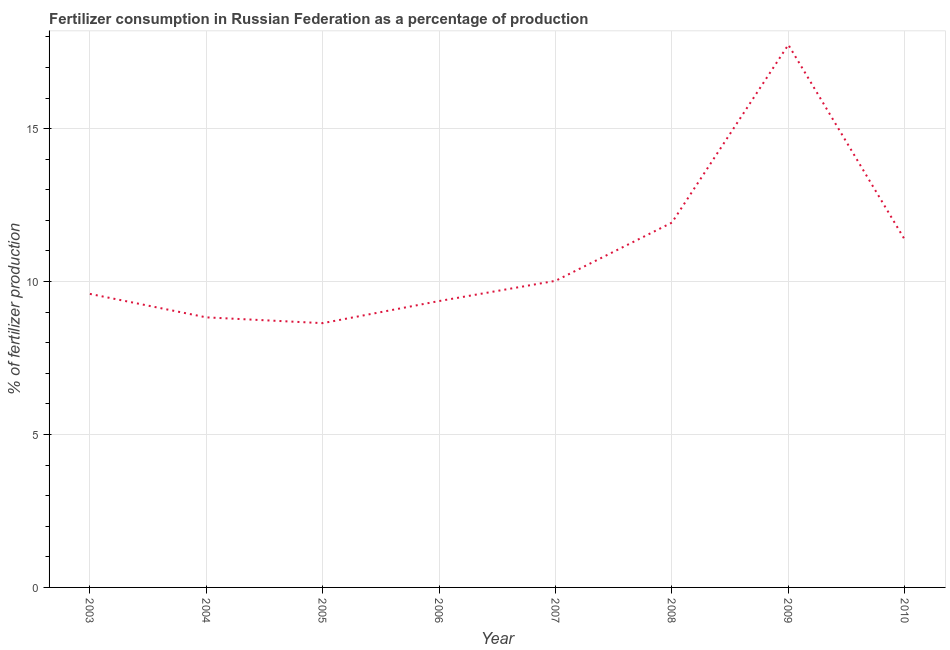What is the amount of fertilizer consumption in 2008?
Provide a succinct answer. 11.93. Across all years, what is the maximum amount of fertilizer consumption?
Give a very brief answer. 17.74. Across all years, what is the minimum amount of fertilizer consumption?
Your response must be concise. 8.64. In which year was the amount of fertilizer consumption minimum?
Provide a short and direct response. 2005. What is the sum of the amount of fertilizer consumption?
Provide a succinct answer. 87.49. What is the difference between the amount of fertilizer consumption in 2003 and 2009?
Your answer should be very brief. -8.15. What is the average amount of fertilizer consumption per year?
Ensure brevity in your answer.  10.94. What is the median amount of fertilizer consumption?
Give a very brief answer. 9.81. In how many years, is the amount of fertilizer consumption greater than 1 %?
Keep it short and to the point. 8. What is the ratio of the amount of fertilizer consumption in 2004 to that in 2008?
Keep it short and to the point. 0.74. Is the amount of fertilizer consumption in 2005 less than that in 2007?
Offer a terse response. Yes. Is the difference between the amount of fertilizer consumption in 2005 and 2007 greater than the difference between any two years?
Make the answer very short. No. What is the difference between the highest and the second highest amount of fertilizer consumption?
Provide a succinct answer. 5.81. Is the sum of the amount of fertilizer consumption in 2008 and 2010 greater than the maximum amount of fertilizer consumption across all years?
Provide a succinct answer. Yes. What is the difference between the highest and the lowest amount of fertilizer consumption?
Provide a succinct answer. 9.1. How many lines are there?
Your response must be concise. 1. What is the difference between two consecutive major ticks on the Y-axis?
Your answer should be compact. 5. Does the graph contain any zero values?
Offer a very short reply. No. What is the title of the graph?
Keep it short and to the point. Fertilizer consumption in Russian Federation as a percentage of production. What is the label or title of the X-axis?
Your answer should be very brief. Year. What is the label or title of the Y-axis?
Give a very brief answer. % of fertilizer production. What is the % of fertilizer production in 2003?
Your answer should be compact. 9.6. What is the % of fertilizer production in 2004?
Provide a short and direct response. 8.83. What is the % of fertilizer production in 2005?
Your answer should be very brief. 8.64. What is the % of fertilizer production in 2006?
Provide a succinct answer. 9.36. What is the % of fertilizer production of 2007?
Offer a terse response. 10.02. What is the % of fertilizer production in 2008?
Your response must be concise. 11.93. What is the % of fertilizer production of 2009?
Offer a very short reply. 17.74. What is the % of fertilizer production of 2010?
Provide a succinct answer. 11.37. What is the difference between the % of fertilizer production in 2003 and 2004?
Your answer should be very brief. 0.77. What is the difference between the % of fertilizer production in 2003 and 2005?
Provide a short and direct response. 0.96. What is the difference between the % of fertilizer production in 2003 and 2006?
Give a very brief answer. 0.23. What is the difference between the % of fertilizer production in 2003 and 2007?
Provide a succinct answer. -0.43. What is the difference between the % of fertilizer production in 2003 and 2008?
Your answer should be compact. -2.33. What is the difference between the % of fertilizer production in 2003 and 2009?
Offer a very short reply. -8.15. What is the difference between the % of fertilizer production in 2003 and 2010?
Your answer should be very brief. -1.77. What is the difference between the % of fertilizer production in 2004 and 2005?
Provide a short and direct response. 0.19. What is the difference between the % of fertilizer production in 2004 and 2006?
Keep it short and to the point. -0.53. What is the difference between the % of fertilizer production in 2004 and 2007?
Your response must be concise. -1.19. What is the difference between the % of fertilizer production in 2004 and 2008?
Your answer should be very brief. -3.1. What is the difference between the % of fertilizer production in 2004 and 2009?
Your response must be concise. -8.91. What is the difference between the % of fertilizer production in 2004 and 2010?
Your response must be concise. -2.54. What is the difference between the % of fertilizer production in 2005 and 2006?
Provide a short and direct response. -0.72. What is the difference between the % of fertilizer production in 2005 and 2007?
Offer a very short reply. -1.38. What is the difference between the % of fertilizer production in 2005 and 2008?
Keep it short and to the point. -3.29. What is the difference between the % of fertilizer production in 2005 and 2009?
Offer a terse response. -9.1. What is the difference between the % of fertilizer production in 2005 and 2010?
Your answer should be very brief. -2.73. What is the difference between the % of fertilizer production in 2006 and 2007?
Your answer should be compact. -0.66. What is the difference between the % of fertilizer production in 2006 and 2008?
Provide a succinct answer. -2.56. What is the difference between the % of fertilizer production in 2006 and 2009?
Make the answer very short. -8.38. What is the difference between the % of fertilizer production in 2006 and 2010?
Your response must be concise. -2.01. What is the difference between the % of fertilizer production in 2007 and 2008?
Keep it short and to the point. -1.9. What is the difference between the % of fertilizer production in 2007 and 2009?
Provide a short and direct response. -7.72. What is the difference between the % of fertilizer production in 2007 and 2010?
Offer a terse response. -1.35. What is the difference between the % of fertilizer production in 2008 and 2009?
Ensure brevity in your answer.  -5.81. What is the difference between the % of fertilizer production in 2008 and 2010?
Your response must be concise. 0.56. What is the difference between the % of fertilizer production in 2009 and 2010?
Give a very brief answer. 6.37. What is the ratio of the % of fertilizer production in 2003 to that in 2004?
Your response must be concise. 1.09. What is the ratio of the % of fertilizer production in 2003 to that in 2005?
Provide a short and direct response. 1.11. What is the ratio of the % of fertilizer production in 2003 to that in 2007?
Make the answer very short. 0.96. What is the ratio of the % of fertilizer production in 2003 to that in 2008?
Your response must be concise. 0.81. What is the ratio of the % of fertilizer production in 2003 to that in 2009?
Keep it short and to the point. 0.54. What is the ratio of the % of fertilizer production in 2003 to that in 2010?
Provide a short and direct response. 0.84. What is the ratio of the % of fertilizer production in 2004 to that in 2005?
Offer a very short reply. 1.02. What is the ratio of the % of fertilizer production in 2004 to that in 2006?
Your answer should be compact. 0.94. What is the ratio of the % of fertilizer production in 2004 to that in 2007?
Offer a terse response. 0.88. What is the ratio of the % of fertilizer production in 2004 to that in 2008?
Provide a succinct answer. 0.74. What is the ratio of the % of fertilizer production in 2004 to that in 2009?
Your response must be concise. 0.5. What is the ratio of the % of fertilizer production in 2004 to that in 2010?
Give a very brief answer. 0.78. What is the ratio of the % of fertilizer production in 2005 to that in 2006?
Make the answer very short. 0.92. What is the ratio of the % of fertilizer production in 2005 to that in 2007?
Your answer should be very brief. 0.86. What is the ratio of the % of fertilizer production in 2005 to that in 2008?
Ensure brevity in your answer.  0.72. What is the ratio of the % of fertilizer production in 2005 to that in 2009?
Keep it short and to the point. 0.49. What is the ratio of the % of fertilizer production in 2005 to that in 2010?
Provide a succinct answer. 0.76. What is the ratio of the % of fertilizer production in 2006 to that in 2007?
Offer a terse response. 0.93. What is the ratio of the % of fertilizer production in 2006 to that in 2008?
Your answer should be compact. 0.79. What is the ratio of the % of fertilizer production in 2006 to that in 2009?
Your response must be concise. 0.53. What is the ratio of the % of fertilizer production in 2006 to that in 2010?
Make the answer very short. 0.82. What is the ratio of the % of fertilizer production in 2007 to that in 2008?
Your answer should be compact. 0.84. What is the ratio of the % of fertilizer production in 2007 to that in 2009?
Your response must be concise. 0.56. What is the ratio of the % of fertilizer production in 2007 to that in 2010?
Provide a succinct answer. 0.88. What is the ratio of the % of fertilizer production in 2008 to that in 2009?
Give a very brief answer. 0.67. What is the ratio of the % of fertilizer production in 2008 to that in 2010?
Offer a terse response. 1.05. What is the ratio of the % of fertilizer production in 2009 to that in 2010?
Keep it short and to the point. 1.56. 